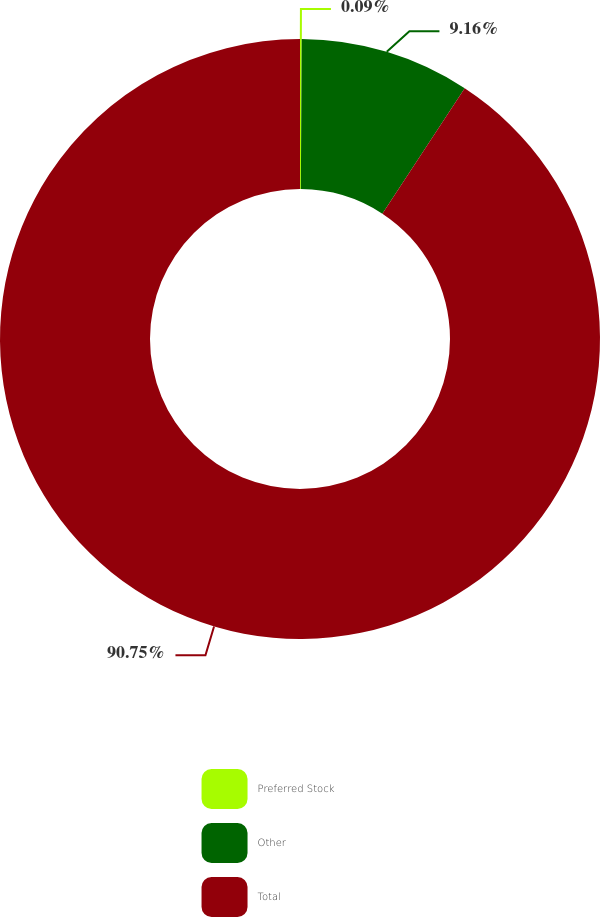Convert chart. <chart><loc_0><loc_0><loc_500><loc_500><pie_chart><fcel>Preferred Stock<fcel>Other<fcel>Total<nl><fcel>0.09%<fcel>9.16%<fcel>90.75%<nl></chart> 